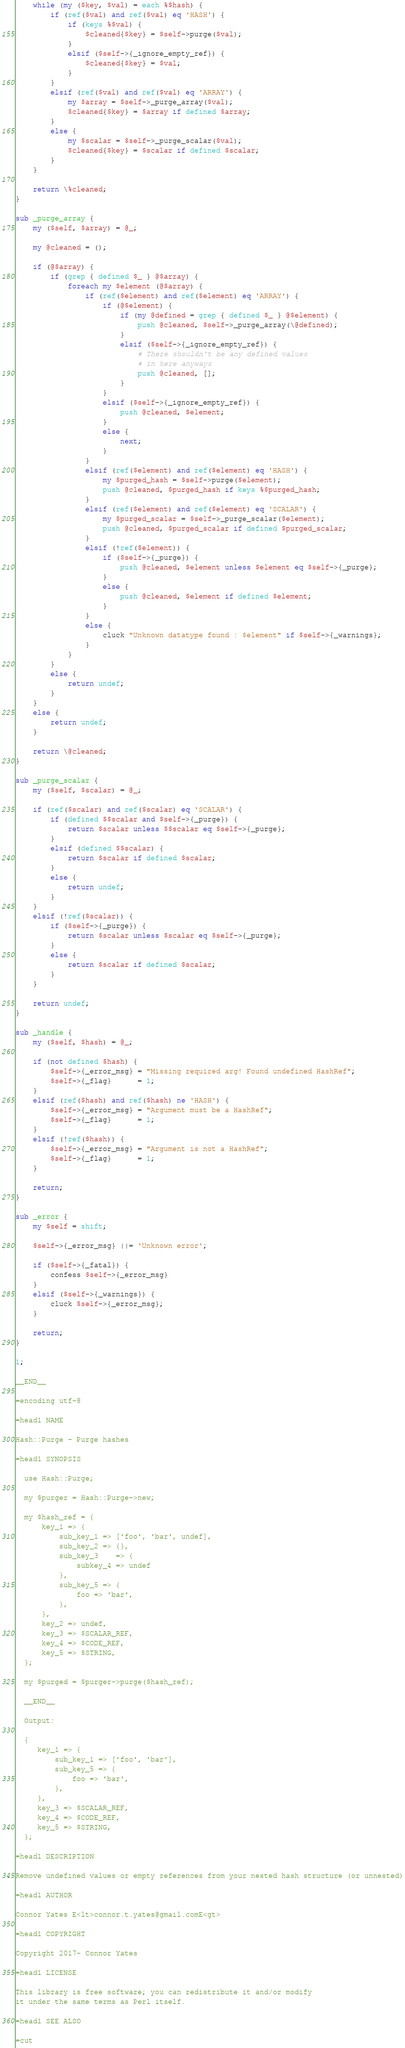Convert code to text. <code><loc_0><loc_0><loc_500><loc_500><_Perl_>
    while (my ($key, $val) = each %$hash) {
        if (ref($val) and ref($val) eq 'HASH') {
            if (keys %$val) {
                $cleaned{$key} = $self->purge($val);
            }
            elsif ($self->{_ignore_empty_ref}) {
                $cleaned{$key} = $val;
            }
        }
        elsif (ref($val) and ref($val) eq 'ARRAY') {
            my $array = $self->_purge_array($val);
            $cleaned{$key} = $array if defined $array;
        }
        else {
            my $scalar = $self->_purge_scalar($val);
            $cleaned{$key} = $scalar if defined $scalar;
        }
    }

    return \%cleaned;
}

sub _purge_array {
    my ($self, $array) = @_;

    my @cleaned = ();

    if (@$array) {
        if (grep { defined $_ } @$array) {
            foreach my $element (@$array) {
                if (ref($element) and ref($element) eq 'ARRAY') {
                    if (@$element) {
                        if (my @defined = grep { defined $_ } @$element) {
                            push @cleaned, $self->_purge_array(\@defined);
                        }
                        elsif ($self->{_ignore_empty_ref}) {
                            # There shouldn't be any defined values
                            # in here anyways
                            push @cleaned, [];
                        }
                    }
                    elsif ($self->{_ignore_empty_ref}) {
                        push @cleaned, $element;
                    }
                    else {
                        next;
                    }
                }
                elsif (ref($element) and ref($element) eq 'HASH') {
                    my $purged_hash = $self->purge($element);
                    push @cleaned, $purged_hash if keys %$purged_hash;
                }
                elsif (ref($element) and ref($element) eq 'SCALAR') {
                    my $purged_scalar = $self->_purge_scalar($element);
                    push @cleaned, $purged_scalar if defined $purged_scalar;
                }
                elsif (!ref($element)) {
                    if ($self->{_purge}) {
                        push @cleaned, $element unless $element eq $self->{_purge};
                    }
                    else {
                        push @cleaned, $element if defined $element;
                    }
                }
                else {
                    cluck "Unknown datatype found : $element" if $self->{_warnings};
                }
            }
        }
        else {
            return undef;
        }
    }
    else {
        return undef;
    }

    return \@cleaned;
}

sub _purge_scalar {
    my ($self, $scalar) = @_;

    if (ref($scalar) and ref($scalar) eq 'SCALAR') {
        if (defined $$scalar and $self->{_purge}) {
            return $scalar unless $$scalar eq $self->{_purge};
        }
        elsif (defined $$scalar) {
            return $scalar if defined $scalar;
        }
        else {
            return undef;
        }
    }
    elsif (!ref($scalar)) {
        if ($self->{_purge}) {
            return $scalar unless $scalar eq $self->{_purge};
        }
        else {
            return $scalar if defined $scalar;
        }
    }

    return undef;
}

sub _handle {
    my ($self, $hash) = @_;

    if (not defined $hash) {
        $self->{_error_msg} = "Missing required arg! Found undefined HashRef";
        $self->{_flag}      = 1;
    }
    elsif (ref($hash) and ref($hash) ne 'HASH') {
        $self->{_error_msg} = "Argument must be a HashRef";
        $self->{_flag}      = 1;
    }
    elsif (!ref($hash)) {
        $self->{_error_msg} = "Argument is not a HashRef";
        $self->{_flag}      = 1;
    }

    return;
}

sub _error {
    my $self = shift;

    $self->{_error_msg} ||= 'Unknown error';

    if ($self->{_fatal}) {
        confess $self->{_error_msg}
    }
    elsif ($self->{_warnings}) {
        cluck $self->{_error_msg};
    }

    return;
}

1;

__END__

=encoding utf-8

=head1 NAME

Hash::Purge - Purge hashes

=head1 SYNOPSIS

  use Hash::Purge;

  my $purger = Hash::Purge->new;

  my $hash_ref = {
      key_1 => {
          sub_key_1 => ['foo', 'bar', undef],
          sub_key_2 => {},
          sub_key_3    => {
              subkey_4 => undef
          },
          sub_key_5 => {
              foo => 'bar',
          },
      },
      key_2 => undef,
      key_3 => $SCALAR_REF,
      key_4 => $CODE_REF,
      key_5 => $STRING,
  };

  my $purged = $purger->purge($hash_ref);

  __END__

  Output:

  {
     key_1 => {
         sub_key_1 => ['foo', 'bar'],
         sub_key_5 => {
             foo => 'bar',
         },
     },
     key_3 => $SCALAR_REF,
     key_4 => $CODE_REF,
     key_5 => $STRING,
  };

=head1 DESCRIPTION

Remove undefined values or empty references from your nested hash structure (or unnested)

=head1 AUTHOR

Connor Yates E<lt>connor.t.yates@gmail.comE<gt>

=head1 COPYRIGHT

Copyright 2017- Connor Yates

=head1 LICENSE

This library is free software; you can redistribute it and/or modify
it under the same terms as Perl itself.

=head1 SEE ALSO

=cut
</code> 